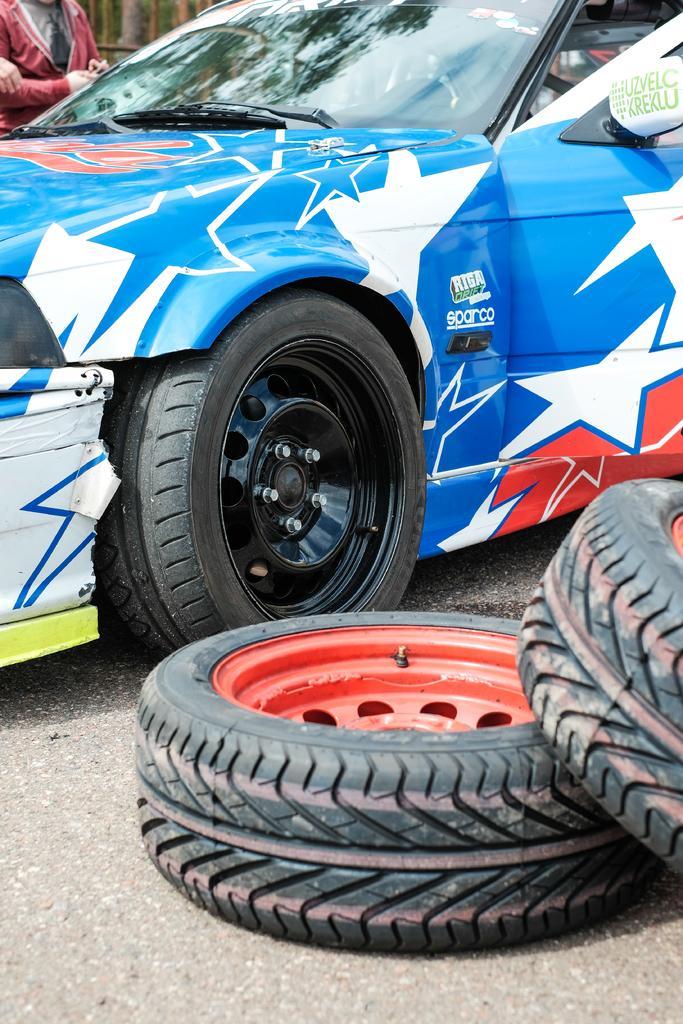Please provide a concise description of this image. In this image we can see a motor vehicle, tyres and a person on the ground. 